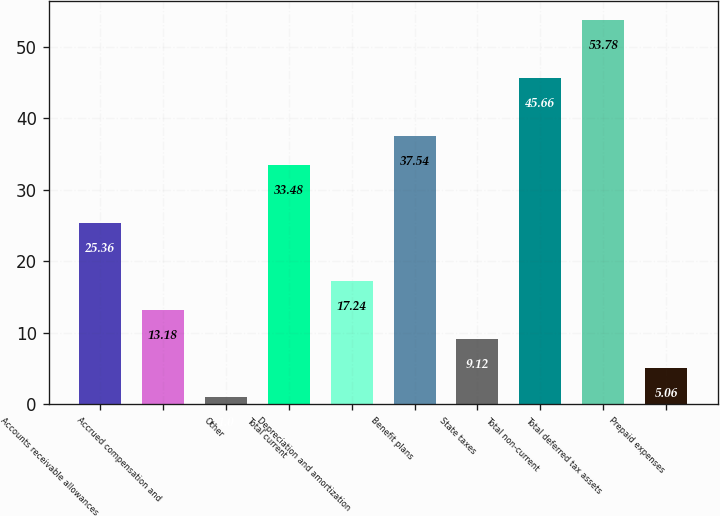<chart> <loc_0><loc_0><loc_500><loc_500><bar_chart><fcel>Accounts receivable allowances<fcel>Accrued compensation and<fcel>Other<fcel>Total current<fcel>Depreciation and amortization<fcel>Benefit plans<fcel>State taxes<fcel>Total non-current<fcel>Total deferred tax assets<fcel>Prepaid expenses<nl><fcel>25.36<fcel>13.18<fcel>1<fcel>33.48<fcel>17.24<fcel>37.54<fcel>9.12<fcel>45.66<fcel>53.78<fcel>5.06<nl></chart> 